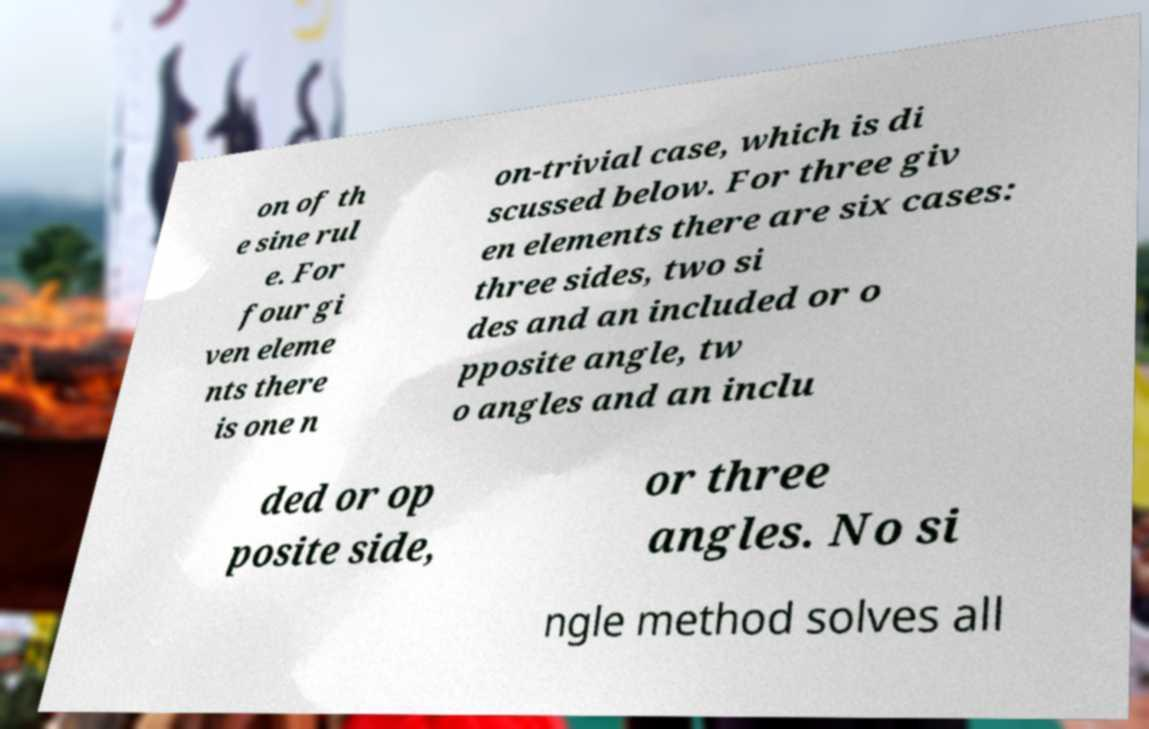What messages or text are displayed in this image? I need them in a readable, typed format. on of th e sine rul e. For four gi ven eleme nts there is one n on-trivial case, which is di scussed below. For three giv en elements there are six cases: three sides, two si des and an included or o pposite angle, tw o angles and an inclu ded or op posite side, or three angles. No si ngle method solves all 